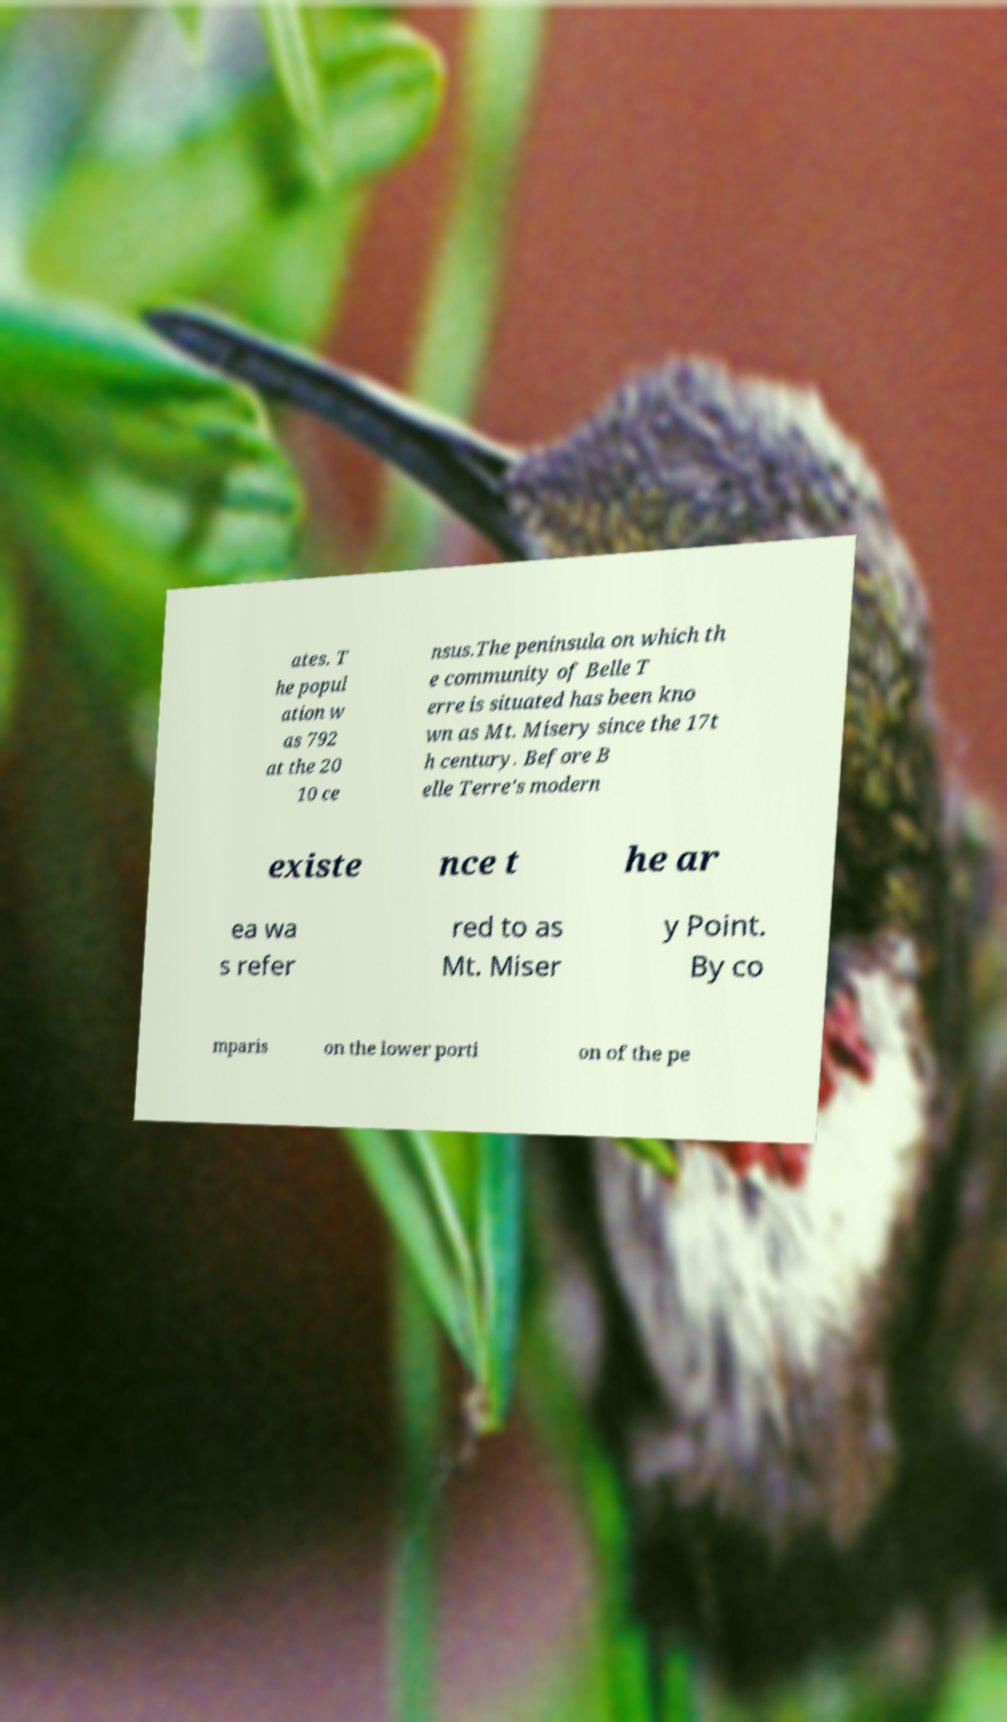Can you accurately transcribe the text from the provided image for me? ates. T he popul ation w as 792 at the 20 10 ce nsus.The peninsula on which th e community of Belle T erre is situated has been kno wn as Mt. Misery since the 17t h century. Before B elle Terre's modern existe nce t he ar ea wa s refer red to as Mt. Miser y Point. By co mparis on the lower porti on of the pe 